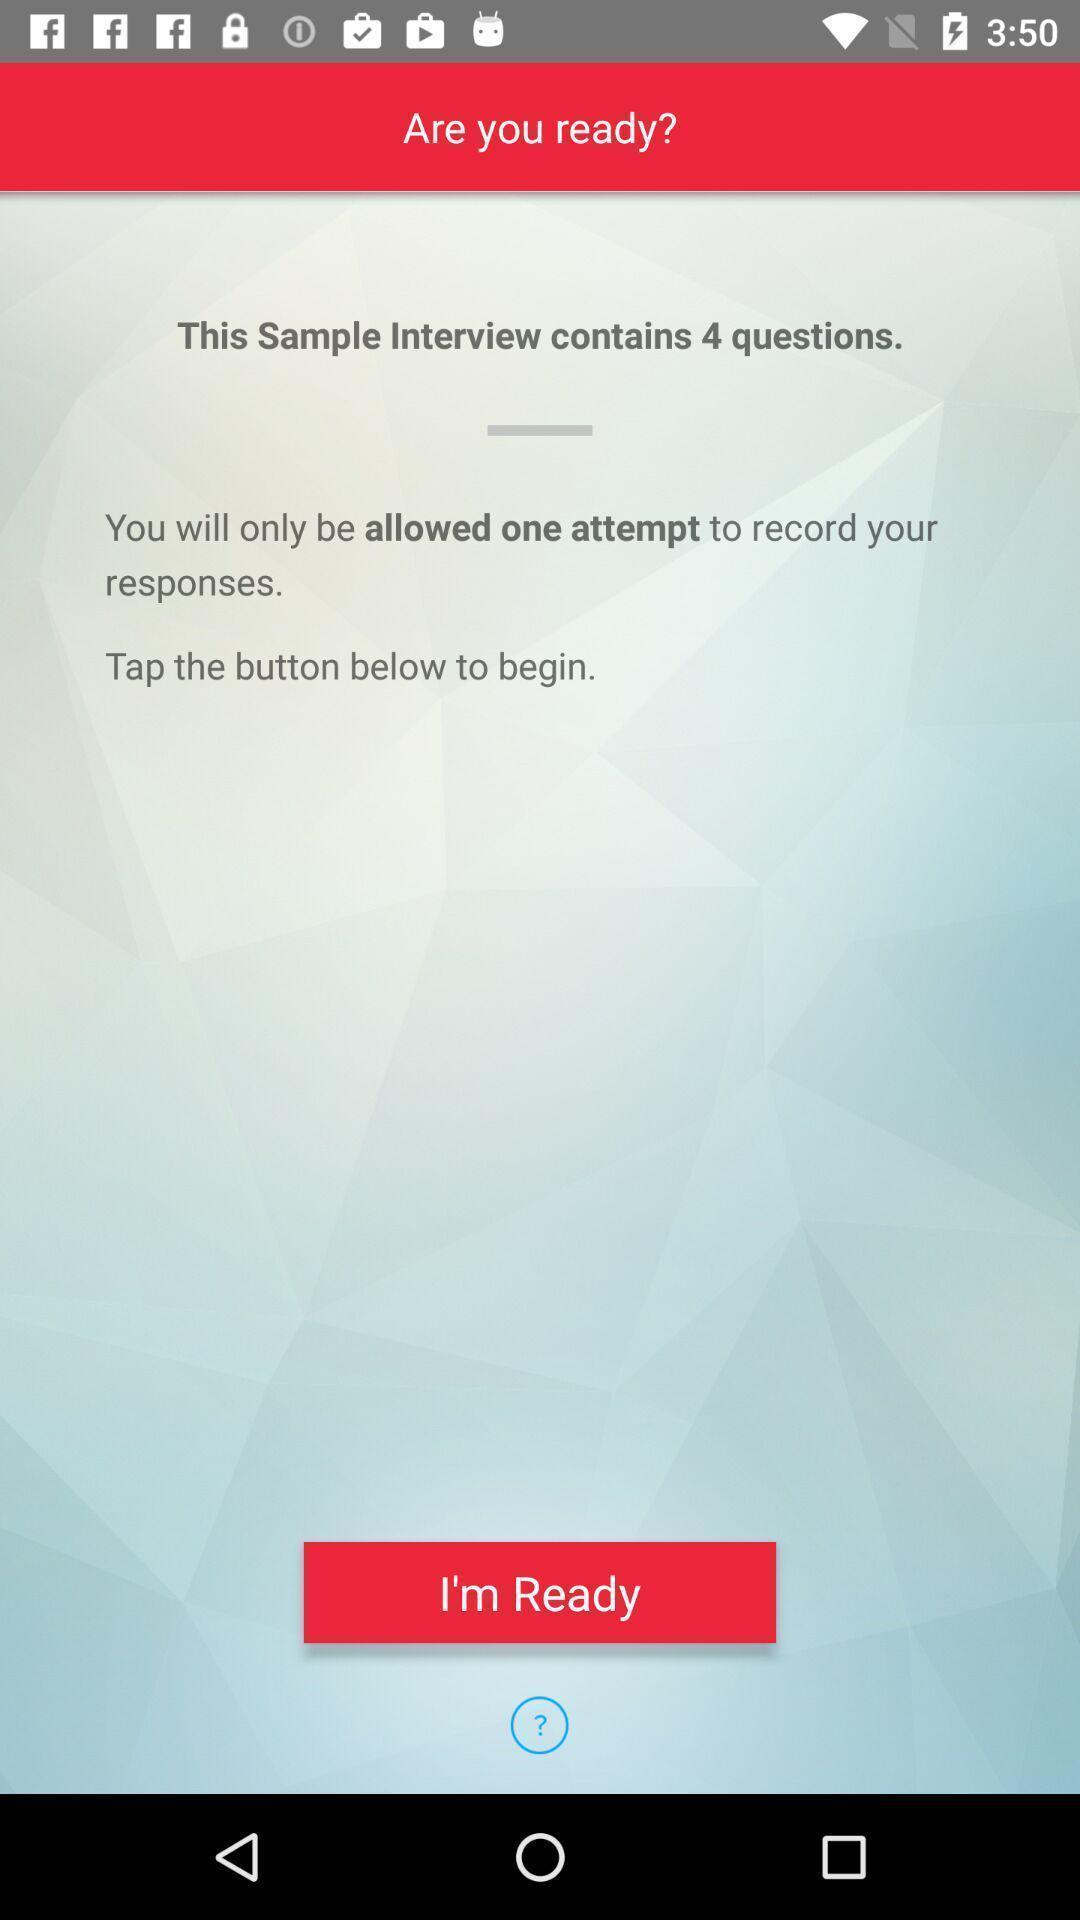Summarize the main components in this picture. Start page of a video interview app. 